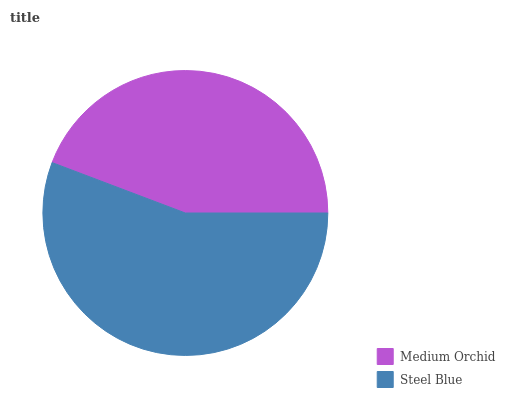Is Medium Orchid the minimum?
Answer yes or no. Yes. Is Steel Blue the maximum?
Answer yes or no. Yes. Is Steel Blue the minimum?
Answer yes or no. No. Is Steel Blue greater than Medium Orchid?
Answer yes or no. Yes. Is Medium Orchid less than Steel Blue?
Answer yes or no. Yes. Is Medium Orchid greater than Steel Blue?
Answer yes or no. No. Is Steel Blue less than Medium Orchid?
Answer yes or no. No. Is Steel Blue the high median?
Answer yes or no. Yes. Is Medium Orchid the low median?
Answer yes or no. Yes. Is Medium Orchid the high median?
Answer yes or no. No. Is Steel Blue the low median?
Answer yes or no. No. 